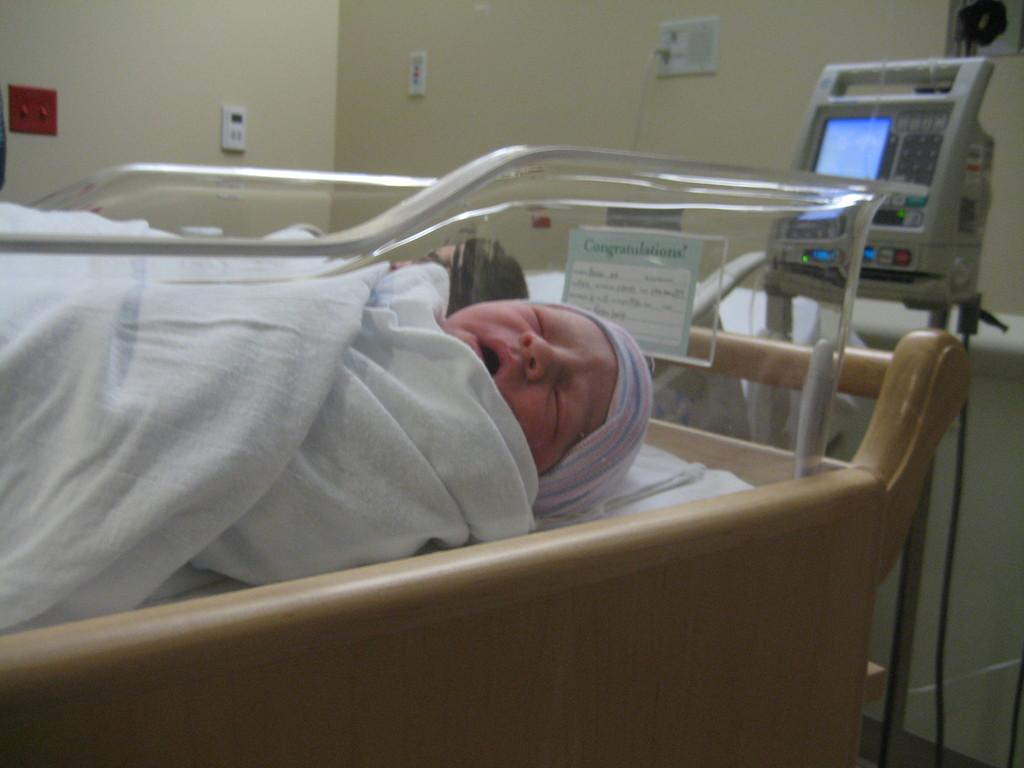What is the main subject of the image? The main subject of the image is a baby sleeping. Where is the baby sleeping? The baby is in an incubator crib. What other objects can be seen in the image? There is a machine with a screen and a socket in the image. How is the socket connected to the wall? The socket is attached to the wall. Can you see a receipt for the bird in the image? There is no receipt or bird present in the image. 